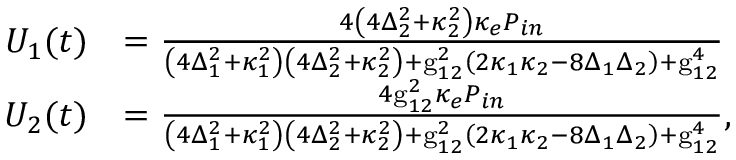Convert formula to latex. <formula><loc_0><loc_0><loc_500><loc_500>\begin{array} { r l } { U _ { 1 } ( t ) } & { = \frac { 4 \left ( 4 \Delta _ { 2 } ^ { 2 } + \kappa _ { 2 } ^ { 2 } \right ) \kappa _ { e } P _ { i n } } { \left ( 4 \Delta _ { 1 } ^ { 2 } + \kappa _ { 1 } ^ { 2 } \right ) \left ( 4 \Delta _ { 2 } ^ { 2 } + \kappa _ { 2 } ^ { 2 } \right ) + g _ { 1 2 } ^ { 2 } \left ( 2 \kappa _ { 1 } \kappa _ { 2 } - 8 \Delta _ { 1 } \Delta _ { 2 } \right ) + g _ { 1 2 } ^ { 4 } } } \\ { U _ { 2 } ( t ) } & { = \frac { 4 g _ { 1 2 } ^ { 2 } \kappa _ { e } P _ { i n } } { \left ( 4 \Delta _ { 1 } ^ { 2 } + \kappa _ { 1 } ^ { 2 } \right ) \left ( 4 \Delta _ { 2 } ^ { 2 } + \kappa _ { 2 } ^ { 2 } \right ) + g _ { 1 2 } ^ { 2 } \left ( 2 \kappa _ { 1 } \kappa _ { 2 } - 8 \Delta _ { 1 } \Delta _ { 2 } \right ) + g _ { 1 2 } ^ { 4 } } , } \end{array}</formula> 